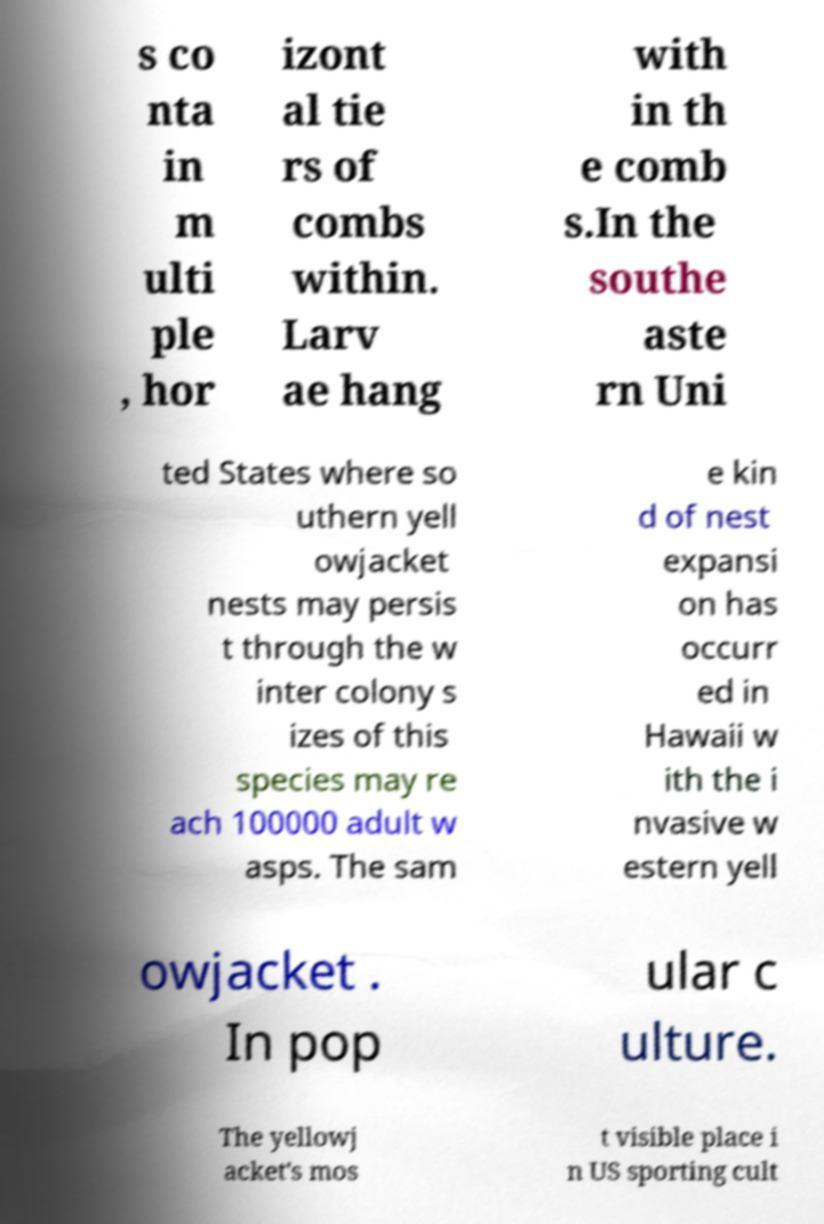I need the written content from this picture converted into text. Can you do that? s co nta in m ulti ple , hor izont al tie rs of combs within. Larv ae hang with in th e comb s.In the southe aste rn Uni ted States where so uthern yell owjacket nests may persis t through the w inter colony s izes of this species may re ach 100000 adult w asps. The sam e kin d of nest expansi on has occurr ed in Hawaii w ith the i nvasive w estern yell owjacket . In pop ular c ulture. The yellowj acket's mos t visible place i n US sporting cult 